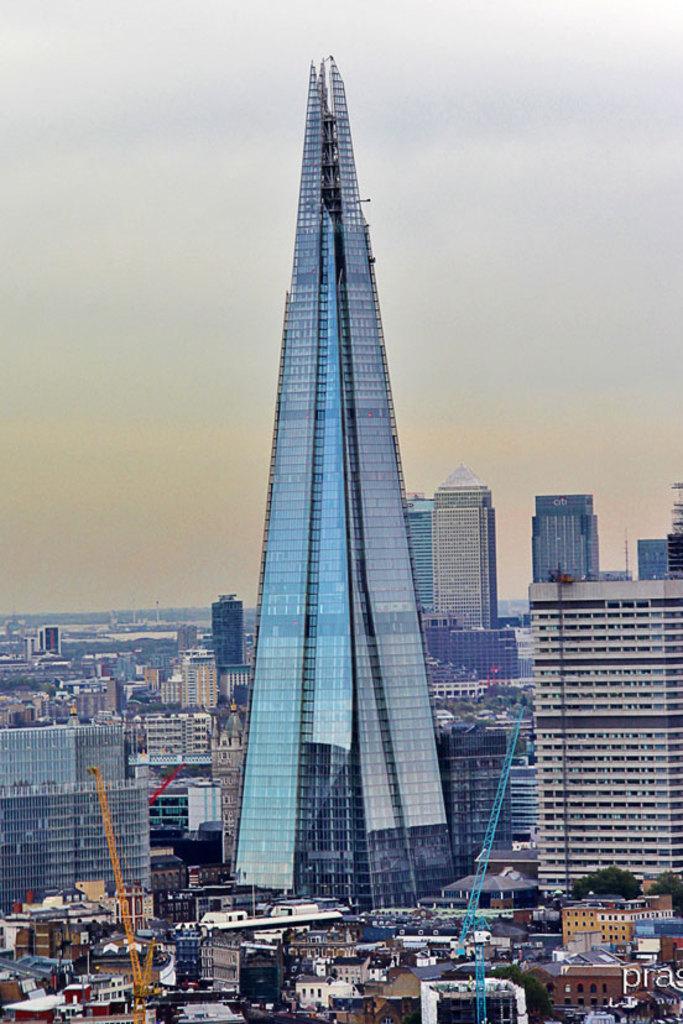Describe this image in one or two sentences. In the picture we can see a city with houses, buildings, tower buildings with glasses in it and behind it also we can see many buildings and a sky. 